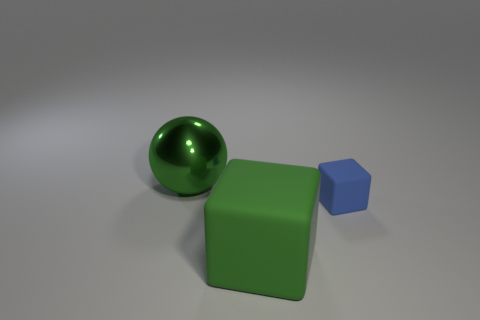Subtract all brown balls. Subtract all cyan cubes. How many balls are left? 1 Add 1 blue objects. How many objects exist? 4 Subtract all balls. How many objects are left? 2 Add 2 big objects. How many big objects are left? 4 Add 1 small matte things. How many small matte things exist? 2 Subtract 0 blue spheres. How many objects are left? 3 Subtract all tiny things. Subtract all big matte things. How many objects are left? 1 